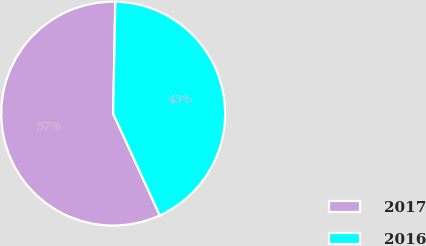Convert chart to OTSL. <chart><loc_0><loc_0><loc_500><loc_500><pie_chart><fcel>2017<fcel>2016<nl><fcel>57.14%<fcel>42.86%<nl></chart> 